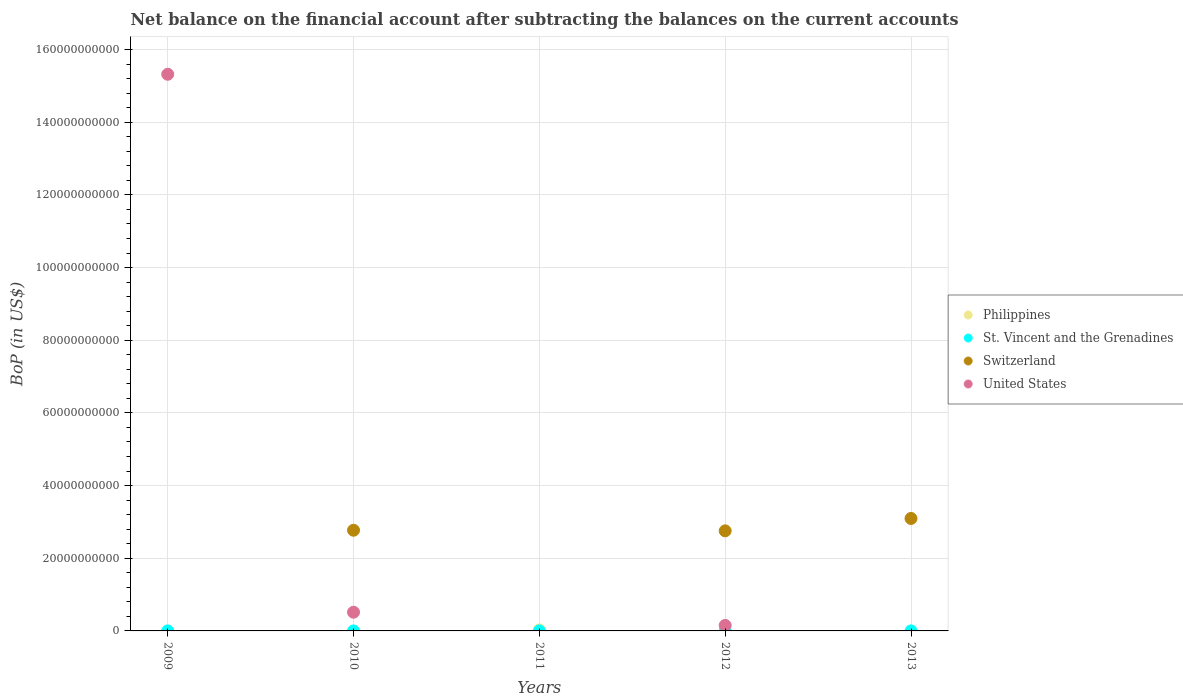Is the number of dotlines equal to the number of legend labels?
Your answer should be compact. No. What is the Balance of Payments in St. Vincent and the Grenadines in 2013?
Keep it short and to the point. 1.26e+07. Across all years, what is the maximum Balance of Payments in Philippines?
Your answer should be very brief. 2.79e+08. What is the total Balance of Payments in United States in the graph?
Provide a succinct answer. 1.60e+11. What is the difference between the Balance of Payments in Switzerland in 2010 and that in 2012?
Keep it short and to the point. 1.63e+08. What is the difference between the Balance of Payments in Philippines in 2012 and the Balance of Payments in Switzerland in 2010?
Your answer should be very brief. -2.77e+1. What is the average Balance of Payments in Philippines per year?
Your response must be concise. 5.58e+07. In the year 2011, what is the difference between the Balance of Payments in Philippines and Balance of Payments in St. Vincent and the Grenadines?
Offer a terse response. 2.74e+08. In how many years, is the Balance of Payments in Switzerland greater than 132000000000 US$?
Ensure brevity in your answer.  0. What is the ratio of the Balance of Payments in St. Vincent and the Grenadines in 2009 to that in 2010?
Provide a short and direct response. 3.55. What is the difference between the highest and the second highest Balance of Payments in United States?
Your answer should be very brief. 1.48e+11. What is the difference between the highest and the lowest Balance of Payments in United States?
Provide a succinct answer. 1.53e+11. In how many years, is the Balance of Payments in Philippines greater than the average Balance of Payments in Philippines taken over all years?
Provide a short and direct response. 1. Does the Balance of Payments in United States monotonically increase over the years?
Provide a succinct answer. No. Is the Balance of Payments in St. Vincent and the Grenadines strictly less than the Balance of Payments in United States over the years?
Your answer should be very brief. No. How many years are there in the graph?
Offer a terse response. 5. What is the difference between two consecutive major ticks on the Y-axis?
Make the answer very short. 2.00e+1. What is the title of the graph?
Offer a terse response. Net balance on the financial account after subtracting the balances on the current accounts. What is the label or title of the Y-axis?
Give a very brief answer. BoP (in US$). What is the BoP (in US$) of Philippines in 2009?
Your answer should be compact. 0. What is the BoP (in US$) in St. Vincent and the Grenadines in 2009?
Ensure brevity in your answer.  6.35e+06. What is the BoP (in US$) in Switzerland in 2009?
Give a very brief answer. 0. What is the BoP (in US$) of United States in 2009?
Provide a succinct answer. 1.53e+11. What is the BoP (in US$) of St. Vincent and the Grenadines in 2010?
Offer a terse response. 1.79e+06. What is the BoP (in US$) in Switzerland in 2010?
Make the answer very short. 2.77e+1. What is the BoP (in US$) in United States in 2010?
Your answer should be very brief. 5.15e+09. What is the BoP (in US$) in Philippines in 2011?
Provide a succinct answer. 2.79e+08. What is the BoP (in US$) in St. Vincent and the Grenadines in 2011?
Provide a short and direct response. 5.15e+06. What is the BoP (in US$) in Switzerland in 2011?
Offer a very short reply. 0. What is the BoP (in US$) of United States in 2011?
Your response must be concise. 0. What is the BoP (in US$) in Philippines in 2012?
Provide a short and direct response. 0. What is the BoP (in US$) of St. Vincent and the Grenadines in 2012?
Give a very brief answer. 0. What is the BoP (in US$) in Switzerland in 2012?
Provide a short and direct response. 2.75e+1. What is the BoP (in US$) in United States in 2012?
Your response must be concise. 1.52e+09. What is the BoP (in US$) of Philippines in 2013?
Your response must be concise. 0. What is the BoP (in US$) in St. Vincent and the Grenadines in 2013?
Offer a very short reply. 1.26e+07. What is the BoP (in US$) of Switzerland in 2013?
Offer a terse response. 3.10e+1. Across all years, what is the maximum BoP (in US$) in Philippines?
Offer a very short reply. 2.79e+08. Across all years, what is the maximum BoP (in US$) in St. Vincent and the Grenadines?
Provide a short and direct response. 1.26e+07. Across all years, what is the maximum BoP (in US$) in Switzerland?
Your response must be concise. 3.10e+1. Across all years, what is the maximum BoP (in US$) of United States?
Offer a very short reply. 1.53e+11. Across all years, what is the minimum BoP (in US$) of St. Vincent and the Grenadines?
Offer a terse response. 0. Across all years, what is the minimum BoP (in US$) in Switzerland?
Ensure brevity in your answer.  0. Across all years, what is the minimum BoP (in US$) in United States?
Provide a succinct answer. 0. What is the total BoP (in US$) of Philippines in the graph?
Your answer should be compact. 2.79e+08. What is the total BoP (in US$) in St. Vincent and the Grenadines in the graph?
Give a very brief answer. 2.58e+07. What is the total BoP (in US$) of Switzerland in the graph?
Provide a succinct answer. 8.62e+1. What is the total BoP (in US$) of United States in the graph?
Provide a succinct answer. 1.60e+11. What is the difference between the BoP (in US$) in St. Vincent and the Grenadines in 2009 and that in 2010?
Your answer should be compact. 4.56e+06. What is the difference between the BoP (in US$) of United States in 2009 and that in 2010?
Provide a short and direct response. 1.48e+11. What is the difference between the BoP (in US$) in St. Vincent and the Grenadines in 2009 and that in 2011?
Keep it short and to the point. 1.20e+06. What is the difference between the BoP (in US$) in United States in 2009 and that in 2012?
Give a very brief answer. 1.52e+11. What is the difference between the BoP (in US$) in St. Vincent and the Grenadines in 2009 and that in 2013?
Give a very brief answer. -6.20e+06. What is the difference between the BoP (in US$) in St. Vincent and the Grenadines in 2010 and that in 2011?
Make the answer very short. -3.36e+06. What is the difference between the BoP (in US$) in Switzerland in 2010 and that in 2012?
Offer a terse response. 1.63e+08. What is the difference between the BoP (in US$) of United States in 2010 and that in 2012?
Your answer should be compact. 3.63e+09. What is the difference between the BoP (in US$) of St. Vincent and the Grenadines in 2010 and that in 2013?
Ensure brevity in your answer.  -1.08e+07. What is the difference between the BoP (in US$) in Switzerland in 2010 and that in 2013?
Offer a terse response. -3.24e+09. What is the difference between the BoP (in US$) in St. Vincent and the Grenadines in 2011 and that in 2013?
Offer a terse response. -7.40e+06. What is the difference between the BoP (in US$) of Switzerland in 2012 and that in 2013?
Your answer should be very brief. -3.41e+09. What is the difference between the BoP (in US$) in St. Vincent and the Grenadines in 2009 and the BoP (in US$) in Switzerland in 2010?
Provide a succinct answer. -2.77e+1. What is the difference between the BoP (in US$) of St. Vincent and the Grenadines in 2009 and the BoP (in US$) of United States in 2010?
Keep it short and to the point. -5.14e+09. What is the difference between the BoP (in US$) of St. Vincent and the Grenadines in 2009 and the BoP (in US$) of Switzerland in 2012?
Make the answer very short. -2.75e+1. What is the difference between the BoP (in US$) in St. Vincent and the Grenadines in 2009 and the BoP (in US$) in United States in 2012?
Provide a short and direct response. -1.51e+09. What is the difference between the BoP (in US$) of St. Vincent and the Grenadines in 2009 and the BoP (in US$) of Switzerland in 2013?
Your answer should be compact. -3.09e+1. What is the difference between the BoP (in US$) in St. Vincent and the Grenadines in 2010 and the BoP (in US$) in Switzerland in 2012?
Make the answer very short. -2.75e+1. What is the difference between the BoP (in US$) in St. Vincent and the Grenadines in 2010 and the BoP (in US$) in United States in 2012?
Your response must be concise. -1.52e+09. What is the difference between the BoP (in US$) in Switzerland in 2010 and the BoP (in US$) in United States in 2012?
Offer a very short reply. 2.62e+1. What is the difference between the BoP (in US$) of St. Vincent and the Grenadines in 2010 and the BoP (in US$) of Switzerland in 2013?
Ensure brevity in your answer.  -3.09e+1. What is the difference between the BoP (in US$) of Philippines in 2011 and the BoP (in US$) of Switzerland in 2012?
Give a very brief answer. -2.73e+1. What is the difference between the BoP (in US$) in Philippines in 2011 and the BoP (in US$) in United States in 2012?
Offer a terse response. -1.24e+09. What is the difference between the BoP (in US$) of St. Vincent and the Grenadines in 2011 and the BoP (in US$) of Switzerland in 2012?
Offer a very short reply. -2.75e+1. What is the difference between the BoP (in US$) in St. Vincent and the Grenadines in 2011 and the BoP (in US$) in United States in 2012?
Offer a very short reply. -1.51e+09. What is the difference between the BoP (in US$) of Philippines in 2011 and the BoP (in US$) of St. Vincent and the Grenadines in 2013?
Make the answer very short. 2.66e+08. What is the difference between the BoP (in US$) of Philippines in 2011 and the BoP (in US$) of Switzerland in 2013?
Ensure brevity in your answer.  -3.07e+1. What is the difference between the BoP (in US$) of St. Vincent and the Grenadines in 2011 and the BoP (in US$) of Switzerland in 2013?
Make the answer very short. -3.09e+1. What is the average BoP (in US$) of Philippines per year?
Keep it short and to the point. 5.58e+07. What is the average BoP (in US$) in St. Vincent and the Grenadines per year?
Make the answer very short. 5.17e+06. What is the average BoP (in US$) in Switzerland per year?
Give a very brief answer. 1.72e+1. What is the average BoP (in US$) in United States per year?
Make the answer very short. 3.20e+1. In the year 2009, what is the difference between the BoP (in US$) of St. Vincent and the Grenadines and BoP (in US$) of United States?
Your answer should be compact. -1.53e+11. In the year 2010, what is the difference between the BoP (in US$) of St. Vincent and the Grenadines and BoP (in US$) of Switzerland?
Give a very brief answer. -2.77e+1. In the year 2010, what is the difference between the BoP (in US$) of St. Vincent and the Grenadines and BoP (in US$) of United States?
Make the answer very short. -5.15e+09. In the year 2010, what is the difference between the BoP (in US$) of Switzerland and BoP (in US$) of United States?
Keep it short and to the point. 2.26e+1. In the year 2011, what is the difference between the BoP (in US$) of Philippines and BoP (in US$) of St. Vincent and the Grenadines?
Provide a short and direct response. 2.74e+08. In the year 2012, what is the difference between the BoP (in US$) in Switzerland and BoP (in US$) in United States?
Your answer should be compact. 2.60e+1. In the year 2013, what is the difference between the BoP (in US$) in St. Vincent and the Grenadines and BoP (in US$) in Switzerland?
Ensure brevity in your answer.  -3.09e+1. What is the ratio of the BoP (in US$) in St. Vincent and the Grenadines in 2009 to that in 2010?
Your answer should be compact. 3.55. What is the ratio of the BoP (in US$) in United States in 2009 to that in 2010?
Offer a very short reply. 29.76. What is the ratio of the BoP (in US$) in St. Vincent and the Grenadines in 2009 to that in 2011?
Your answer should be compact. 1.23. What is the ratio of the BoP (in US$) in United States in 2009 to that in 2012?
Your response must be concise. 100.99. What is the ratio of the BoP (in US$) in St. Vincent and the Grenadines in 2009 to that in 2013?
Ensure brevity in your answer.  0.51. What is the ratio of the BoP (in US$) of St. Vincent and the Grenadines in 2010 to that in 2011?
Provide a succinct answer. 0.35. What is the ratio of the BoP (in US$) of Switzerland in 2010 to that in 2012?
Offer a very short reply. 1.01. What is the ratio of the BoP (in US$) in United States in 2010 to that in 2012?
Your response must be concise. 3.39. What is the ratio of the BoP (in US$) in St. Vincent and the Grenadines in 2010 to that in 2013?
Provide a succinct answer. 0.14. What is the ratio of the BoP (in US$) in Switzerland in 2010 to that in 2013?
Keep it short and to the point. 0.9. What is the ratio of the BoP (in US$) in St. Vincent and the Grenadines in 2011 to that in 2013?
Your answer should be compact. 0.41. What is the ratio of the BoP (in US$) in Switzerland in 2012 to that in 2013?
Keep it short and to the point. 0.89. What is the difference between the highest and the second highest BoP (in US$) of St. Vincent and the Grenadines?
Keep it short and to the point. 6.20e+06. What is the difference between the highest and the second highest BoP (in US$) in Switzerland?
Give a very brief answer. 3.24e+09. What is the difference between the highest and the second highest BoP (in US$) of United States?
Offer a very short reply. 1.48e+11. What is the difference between the highest and the lowest BoP (in US$) of Philippines?
Give a very brief answer. 2.79e+08. What is the difference between the highest and the lowest BoP (in US$) in St. Vincent and the Grenadines?
Your answer should be compact. 1.26e+07. What is the difference between the highest and the lowest BoP (in US$) in Switzerland?
Give a very brief answer. 3.10e+1. What is the difference between the highest and the lowest BoP (in US$) of United States?
Offer a terse response. 1.53e+11. 